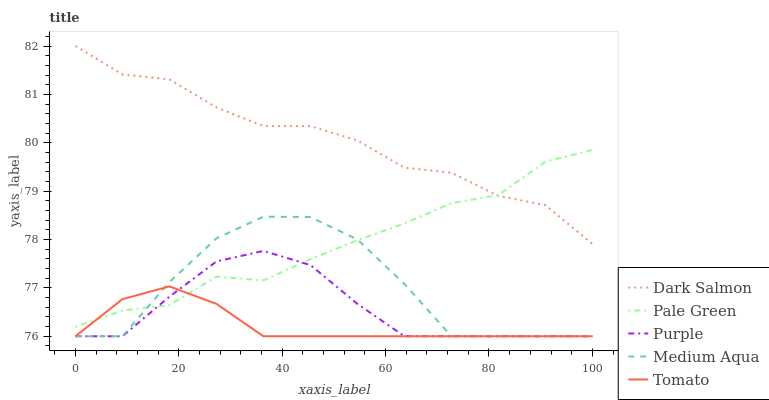Does Tomato have the minimum area under the curve?
Answer yes or no. Yes. Does Dark Salmon have the maximum area under the curve?
Answer yes or no. Yes. Does Pale Green have the minimum area under the curve?
Answer yes or no. No. Does Pale Green have the maximum area under the curve?
Answer yes or no. No. Is Tomato the smoothest?
Answer yes or no. Yes. Is Medium Aqua the roughest?
Answer yes or no. Yes. Is Pale Green the smoothest?
Answer yes or no. No. Is Pale Green the roughest?
Answer yes or no. No. Does Purple have the lowest value?
Answer yes or no. Yes. Does Pale Green have the lowest value?
Answer yes or no. No. Does Dark Salmon have the highest value?
Answer yes or no. Yes. Does Pale Green have the highest value?
Answer yes or no. No. Is Medium Aqua less than Dark Salmon?
Answer yes or no. Yes. Is Dark Salmon greater than Purple?
Answer yes or no. Yes. Does Medium Aqua intersect Purple?
Answer yes or no. Yes. Is Medium Aqua less than Purple?
Answer yes or no. No. Is Medium Aqua greater than Purple?
Answer yes or no. No. Does Medium Aqua intersect Dark Salmon?
Answer yes or no. No. 